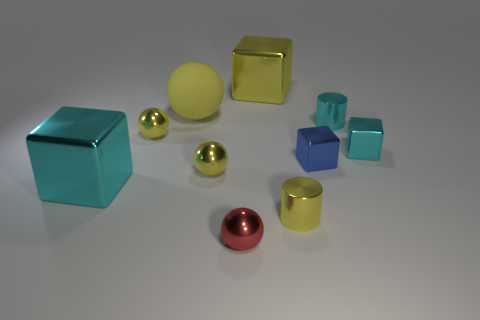Is there a small purple sphere?
Provide a short and direct response. No. There is a shiny sphere behind the cyan metal cube on the right side of the cylinder that is behind the tiny cyan metal cube; what is its size?
Your response must be concise. Small. What number of other objects are the same size as the blue shiny thing?
Make the answer very short. 6. How big is the cyan metallic block on the left side of the tiny blue shiny thing?
Ensure brevity in your answer.  Large. Is there anything else of the same color as the rubber object?
Give a very brief answer. Yes. Do the yellow ball behind the cyan shiny cylinder and the blue object have the same material?
Keep it short and to the point. No. What number of cyan things are left of the big matte ball and behind the big cyan metal thing?
Provide a short and direct response. 0. There is a cyan block right of the small yellow metal object that is on the right side of the tiny red shiny ball; how big is it?
Offer a terse response. Small. Is there anything else that has the same material as the tiny blue block?
Offer a terse response. Yes. Is the number of large yellow cubes greater than the number of yellow things?
Your response must be concise. No. 